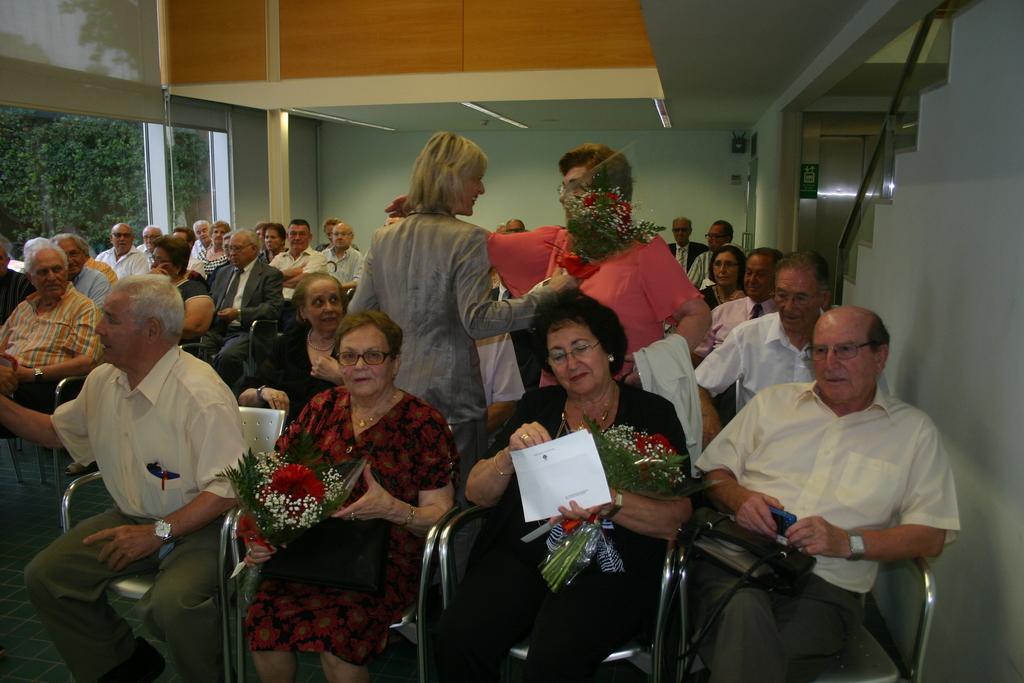Please provide a concise description of this image. In this image, we can see some people sitting on the chairs, in the middle we can see two women sitting and holding the flower bouquets, there are two persons standing, on the right side, we can see some steps, we can see the walls, on the left side there is a glass window. 